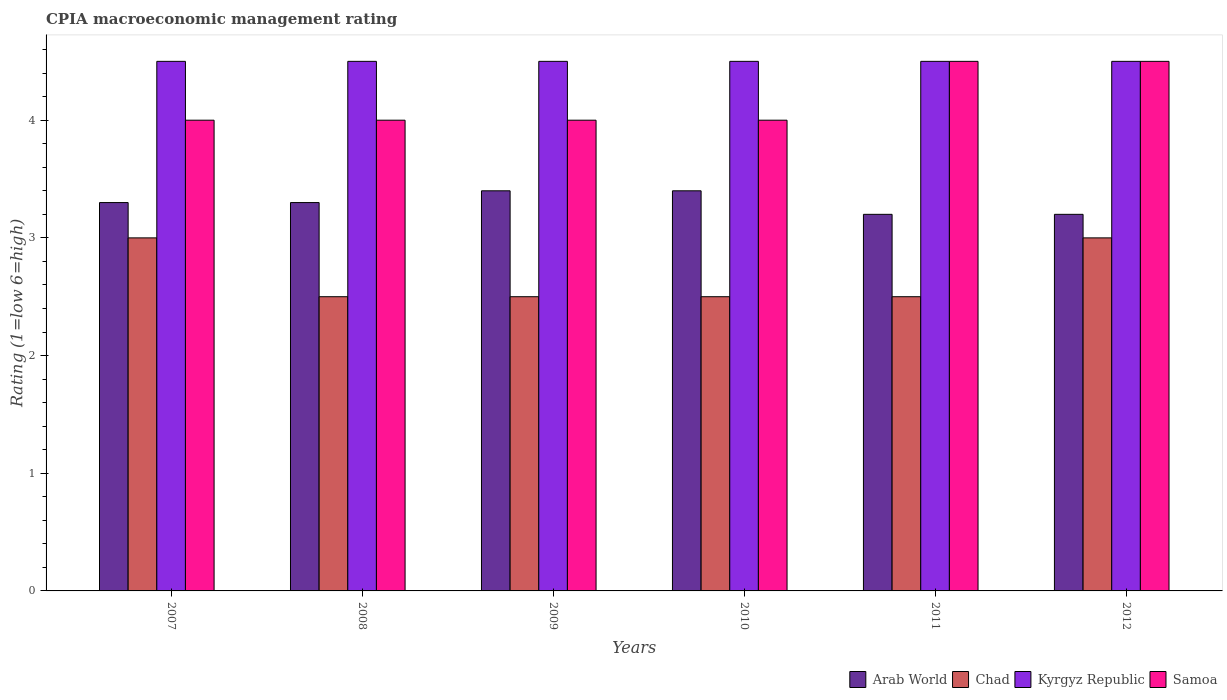Are the number of bars per tick equal to the number of legend labels?
Your response must be concise. Yes. Are the number of bars on each tick of the X-axis equal?
Your answer should be compact. Yes. How many bars are there on the 2nd tick from the left?
Provide a short and direct response. 4. How many bars are there on the 1st tick from the right?
Your answer should be compact. 4. Across all years, what is the maximum CPIA rating in Arab World?
Offer a very short reply. 3.4. Across all years, what is the minimum CPIA rating in Arab World?
Keep it short and to the point. 3.2. In which year was the CPIA rating in Chad minimum?
Offer a very short reply. 2008. What is the total CPIA rating in Samoa in the graph?
Your answer should be very brief. 25. What is the difference between the CPIA rating in Arab World in 2007 and that in 2010?
Offer a terse response. -0.1. What is the difference between the CPIA rating in Chad in 2010 and the CPIA rating in Kyrgyz Republic in 2012?
Provide a short and direct response. -2. What is the average CPIA rating in Arab World per year?
Make the answer very short. 3.3. In the year 2008, what is the difference between the CPIA rating in Chad and CPIA rating in Samoa?
Keep it short and to the point. -1.5. In how many years, is the CPIA rating in Kyrgyz Republic greater than 1.8?
Keep it short and to the point. 6. What is the ratio of the CPIA rating in Samoa in 2010 to that in 2012?
Give a very brief answer. 0.89. What is the difference between the highest and the lowest CPIA rating in Kyrgyz Republic?
Offer a very short reply. 0. Is the sum of the CPIA rating in Samoa in 2010 and 2012 greater than the maximum CPIA rating in Arab World across all years?
Your response must be concise. Yes. What does the 1st bar from the left in 2009 represents?
Your response must be concise. Arab World. What does the 1st bar from the right in 2007 represents?
Keep it short and to the point. Samoa. Is it the case that in every year, the sum of the CPIA rating in Kyrgyz Republic and CPIA rating in Arab World is greater than the CPIA rating in Chad?
Offer a very short reply. Yes. How many bars are there?
Offer a terse response. 24. Are all the bars in the graph horizontal?
Offer a very short reply. No. How many years are there in the graph?
Your response must be concise. 6. Where does the legend appear in the graph?
Your response must be concise. Bottom right. How are the legend labels stacked?
Offer a terse response. Horizontal. What is the title of the graph?
Make the answer very short. CPIA macroeconomic management rating. Does "Greece" appear as one of the legend labels in the graph?
Ensure brevity in your answer.  No. What is the label or title of the Y-axis?
Your answer should be very brief. Rating (1=low 6=high). What is the Rating (1=low 6=high) in Arab World in 2007?
Provide a short and direct response. 3.3. What is the Rating (1=low 6=high) in Samoa in 2008?
Make the answer very short. 4. What is the Rating (1=low 6=high) in Samoa in 2009?
Provide a succinct answer. 4. What is the Rating (1=low 6=high) of Chad in 2010?
Provide a short and direct response. 2.5. What is the Rating (1=low 6=high) of Kyrgyz Republic in 2010?
Provide a short and direct response. 4.5. What is the Rating (1=low 6=high) of Chad in 2011?
Keep it short and to the point. 2.5. What is the Rating (1=low 6=high) in Kyrgyz Republic in 2011?
Your response must be concise. 4.5. What is the Rating (1=low 6=high) of Samoa in 2011?
Your response must be concise. 4.5. What is the Rating (1=low 6=high) in Arab World in 2012?
Your response must be concise. 3.2. What is the Rating (1=low 6=high) of Chad in 2012?
Provide a succinct answer. 3. Across all years, what is the maximum Rating (1=low 6=high) in Kyrgyz Republic?
Ensure brevity in your answer.  4.5. Across all years, what is the minimum Rating (1=low 6=high) of Kyrgyz Republic?
Make the answer very short. 4.5. What is the total Rating (1=low 6=high) in Arab World in the graph?
Ensure brevity in your answer.  19.8. What is the total Rating (1=low 6=high) in Chad in the graph?
Your answer should be compact. 16. What is the difference between the Rating (1=low 6=high) in Arab World in 2007 and that in 2008?
Provide a succinct answer. 0. What is the difference between the Rating (1=low 6=high) in Chad in 2007 and that in 2008?
Your answer should be compact. 0.5. What is the difference between the Rating (1=low 6=high) of Kyrgyz Republic in 2007 and that in 2008?
Provide a succinct answer. 0. What is the difference between the Rating (1=low 6=high) of Chad in 2007 and that in 2010?
Your answer should be compact. 0.5. What is the difference between the Rating (1=low 6=high) in Chad in 2007 and that in 2011?
Ensure brevity in your answer.  0.5. What is the difference between the Rating (1=low 6=high) in Arab World in 2008 and that in 2009?
Offer a terse response. -0.1. What is the difference between the Rating (1=low 6=high) in Kyrgyz Republic in 2008 and that in 2010?
Offer a terse response. 0. What is the difference between the Rating (1=low 6=high) of Arab World in 2008 and that in 2011?
Provide a succinct answer. 0.1. What is the difference between the Rating (1=low 6=high) of Chad in 2008 and that in 2012?
Your answer should be very brief. -0.5. What is the difference between the Rating (1=low 6=high) in Samoa in 2008 and that in 2012?
Offer a very short reply. -0.5. What is the difference between the Rating (1=low 6=high) of Arab World in 2009 and that in 2010?
Provide a succinct answer. 0. What is the difference between the Rating (1=low 6=high) of Chad in 2009 and that in 2010?
Offer a very short reply. 0. What is the difference between the Rating (1=low 6=high) of Chad in 2009 and that in 2011?
Provide a succinct answer. 0. What is the difference between the Rating (1=low 6=high) of Samoa in 2009 and that in 2011?
Offer a very short reply. -0.5. What is the difference between the Rating (1=low 6=high) in Arab World in 2009 and that in 2012?
Your response must be concise. 0.2. What is the difference between the Rating (1=low 6=high) in Chad in 2009 and that in 2012?
Your answer should be very brief. -0.5. What is the difference between the Rating (1=low 6=high) of Kyrgyz Republic in 2009 and that in 2012?
Your answer should be compact. 0. What is the difference between the Rating (1=low 6=high) of Arab World in 2010 and that in 2011?
Give a very brief answer. 0.2. What is the difference between the Rating (1=low 6=high) of Samoa in 2010 and that in 2011?
Give a very brief answer. -0.5. What is the difference between the Rating (1=low 6=high) in Chad in 2010 and that in 2012?
Provide a succinct answer. -0.5. What is the difference between the Rating (1=low 6=high) in Samoa in 2010 and that in 2012?
Your answer should be compact. -0.5. What is the difference between the Rating (1=low 6=high) in Chad in 2011 and that in 2012?
Ensure brevity in your answer.  -0.5. What is the difference between the Rating (1=low 6=high) in Kyrgyz Republic in 2011 and that in 2012?
Provide a succinct answer. 0. What is the difference between the Rating (1=low 6=high) of Arab World in 2007 and the Rating (1=low 6=high) of Chad in 2008?
Provide a short and direct response. 0.8. What is the difference between the Rating (1=low 6=high) in Arab World in 2007 and the Rating (1=low 6=high) in Kyrgyz Republic in 2009?
Your answer should be very brief. -1.2. What is the difference between the Rating (1=low 6=high) in Chad in 2007 and the Rating (1=low 6=high) in Samoa in 2009?
Your response must be concise. -1. What is the difference between the Rating (1=low 6=high) in Kyrgyz Republic in 2007 and the Rating (1=low 6=high) in Samoa in 2009?
Your answer should be compact. 0.5. What is the difference between the Rating (1=low 6=high) in Arab World in 2007 and the Rating (1=low 6=high) in Chad in 2010?
Provide a short and direct response. 0.8. What is the difference between the Rating (1=low 6=high) in Arab World in 2007 and the Rating (1=low 6=high) in Kyrgyz Republic in 2010?
Give a very brief answer. -1.2. What is the difference between the Rating (1=low 6=high) in Arab World in 2007 and the Rating (1=low 6=high) in Samoa in 2010?
Your response must be concise. -0.7. What is the difference between the Rating (1=low 6=high) in Chad in 2007 and the Rating (1=low 6=high) in Kyrgyz Republic in 2010?
Your response must be concise. -1.5. What is the difference between the Rating (1=low 6=high) of Chad in 2007 and the Rating (1=low 6=high) of Samoa in 2010?
Give a very brief answer. -1. What is the difference between the Rating (1=low 6=high) in Kyrgyz Republic in 2007 and the Rating (1=low 6=high) in Samoa in 2010?
Provide a succinct answer. 0.5. What is the difference between the Rating (1=low 6=high) in Arab World in 2007 and the Rating (1=low 6=high) in Kyrgyz Republic in 2011?
Give a very brief answer. -1.2. What is the difference between the Rating (1=low 6=high) in Arab World in 2007 and the Rating (1=low 6=high) in Samoa in 2011?
Give a very brief answer. -1.2. What is the difference between the Rating (1=low 6=high) of Arab World in 2007 and the Rating (1=low 6=high) of Samoa in 2012?
Your response must be concise. -1.2. What is the difference between the Rating (1=low 6=high) of Chad in 2007 and the Rating (1=low 6=high) of Samoa in 2012?
Provide a short and direct response. -1.5. What is the difference between the Rating (1=low 6=high) in Arab World in 2008 and the Rating (1=low 6=high) in Kyrgyz Republic in 2009?
Your answer should be very brief. -1.2. What is the difference between the Rating (1=low 6=high) of Chad in 2008 and the Rating (1=low 6=high) of Kyrgyz Republic in 2009?
Ensure brevity in your answer.  -2. What is the difference between the Rating (1=low 6=high) in Chad in 2008 and the Rating (1=low 6=high) in Samoa in 2009?
Provide a succinct answer. -1.5. What is the difference between the Rating (1=low 6=high) of Arab World in 2008 and the Rating (1=low 6=high) of Chad in 2010?
Your answer should be compact. 0.8. What is the difference between the Rating (1=low 6=high) of Chad in 2008 and the Rating (1=low 6=high) of Samoa in 2010?
Make the answer very short. -1.5. What is the difference between the Rating (1=low 6=high) of Kyrgyz Republic in 2008 and the Rating (1=low 6=high) of Samoa in 2010?
Your answer should be very brief. 0.5. What is the difference between the Rating (1=low 6=high) in Arab World in 2008 and the Rating (1=low 6=high) in Kyrgyz Republic in 2011?
Offer a very short reply. -1.2. What is the difference between the Rating (1=low 6=high) in Chad in 2008 and the Rating (1=low 6=high) in Kyrgyz Republic in 2011?
Your answer should be very brief. -2. What is the difference between the Rating (1=low 6=high) in Kyrgyz Republic in 2008 and the Rating (1=low 6=high) in Samoa in 2011?
Ensure brevity in your answer.  0. What is the difference between the Rating (1=low 6=high) of Chad in 2008 and the Rating (1=low 6=high) of Kyrgyz Republic in 2012?
Provide a short and direct response. -2. What is the difference between the Rating (1=low 6=high) of Chad in 2008 and the Rating (1=low 6=high) of Samoa in 2012?
Provide a short and direct response. -2. What is the difference between the Rating (1=low 6=high) in Arab World in 2009 and the Rating (1=low 6=high) in Samoa in 2010?
Give a very brief answer. -0.6. What is the difference between the Rating (1=low 6=high) in Chad in 2009 and the Rating (1=low 6=high) in Kyrgyz Republic in 2010?
Ensure brevity in your answer.  -2. What is the difference between the Rating (1=low 6=high) in Chad in 2009 and the Rating (1=low 6=high) in Samoa in 2010?
Make the answer very short. -1.5. What is the difference between the Rating (1=low 6=high) of Arab World in 2009 and the Rating (1=low 6=high) of Chad in 2011?
Offer a terse response. 0.9. What is the difference between the Rating (1=low 6=high) in Kyrgyz Republic in 2009 and the Rating (1=low 6=high) in Samoa in 2011?
Keep it short and to the point. 0. What is the difference between the Rating (1=low 6=high) in Arab World in 2009 and the Rating (1=low 6=high) in Samoa in 2012?
Ensure brevity in your answer.  -1.1. What is the difference between the Rating (1=low 6=high) in Chad in 2009 and the Rating (1=low 6=high) in Kyrgyz Republic in 2012?
Your answer should be very brief. -2. What is the difference between the Rating (1=low 6=high) in Arab World in 2010 and the Rating (1=low 6=high) in Chad in 2011?
Make the answer very short. 0.9. What is the difference between the Rating (1=low 6=high) in Chad in 2010 and the Rating (1=low 6=high) in Kyrgyz Republic in 2011?
Provide a succinct answer. -2. What is the difference between the Rating (1=low 6=high) of Chad in 2010 and the Rating (1=low 6=high) of Samoa in 2011?
Your answer should be compact. -2. What is the difference between the Rating (1=low 6=high) in Kyrgyz Republic in 2010 and the Rating (1=low 6=high) in Samoa in 2011?
Keep it short and to the point. 0. What is the difference between the Rating (1=low 6=high) of Arab World in 2010 and the Rating (1=low 6=high) of Chad in 2012?
Give a very brief answer. 0.4. What is the difference between the Rating (1=low 6=high) in Arab World in 2010 and the Rating (1=low 6=high) in Kyrgyz Republic in 2012?
Provide a succinct answer. -1.1. What is the difference between the Rating (1=low 6=high) in Chad in 2010 and the Rating (1=low 6=high) in Samoa in 2012?
Your answer should be very brief. -2. What is the difference between the Rating (1=low 6=high) of Arab World in 2011 and the Rating (1=low 6=high) of Kyrgyz Republic in 2012?
Keep it short and to the point. -1.3. What is the difference between the Rating (1=low 6=high) of Arab World in 2011 and the Rating (1=low 6=high) of Samoa in 2012?
Offer a terse response. -1.3. What is the difference between the Rating (1=low 6=high) in Kyrgyz Republic in 2011 and the Rating (1=low 6=high) in Samoa in 2012?
Give a very brief answer. 0. What is the average Rating (1=low 6=high) of Chad per year?
Offer a very short reply. 2.67. What is the average Rating (1=low 6=high) of Kyrgyz Republic per year?
Your response must be concise. 4.5. What is the average Rating (1=low 6=high) in Samoa per year?
Offer a terse response. 4.17. In the year 2007, what is the difference between the Rating (1=low 6=high) of Kyrgyz Republic and Rating (1=low 6=high) of Samoa?
Provide a succinct answer. 0.5. In the year 2008, what is the difference between the Rating (1=low 6=high) in Arab World and Rating (1=low 6=high) in Kyrgyz Republic?
Give a very brief answer. -1.2. In the year 2008, what is the difference between the Rating (1=low 6=high) of Arab World and Rating (1=low 6=high) of Samoa?
Your answer should be very brief. -0.7. In the year 2008, what is the difference between the Rating (1=low 6=high) of Chad and Rating (1=low 6=high) of Kyrgyz Republic?
Provide a succinct answer. -2. In the year 2008, what is the difference between the Rating (1=low 6=high) of Kyrgyz Republic and Rating (1=low 6=high) of Samoa?
Your answer should be very brief. 0.5. In the year 2009, what is the difference between the Rating (1=low 6=high) of Arab World and Rating (1=low 6=high) of Chad?
Your answer should be very brief. 0.9. In the year 2009, what is the difference between the Rating (1=low 6=high) of Arab World and Rating (1=low 6=high) of Kyrgyz Republic?
Keep it short and to the point. -1.1. In the year 2009, what is the difference between the Rating (1=low 6=high) in Arab World and Rating (1=low 6=high) in Samoa?
Provide a succinct answer. -0.6. In the year 2009, what is the difference between the Rating (1=low 6=high) in Chad and Rating (1=low 6=high) in Kyrgyz Republic?
Ensure brevity in your answer.  -2. In the year 2009, what is the difference between the Rating (1=low 6=high) of Chad and Rating (1=low 6=high) of Samoa?
Ensure brevity in your answer.  -1.5. In the year 2010, what is the difference between the Rating (1=low 6=high) of Kyrgyz Republic and Rating (1=low 6=high) of Samoa?
Ensure brevity in your answer.  0.5. In the year 2011, what is the difference between the Rating (1=low 6=high) of Arab World and Rating (1=low 6=high) of Samoa?
Give a very brief answer. -1.3. In the year 2011, what is the difference between the Rating (1=low 6=high) of Chad and Rating (1=low 6=high) of Kyrgyz Republic?
Provide a succinct answer. -2. In the year 2011, what is the difference between the Rating (1=low 6=high) in Chad and Rating (1=low 6=high) in Samoa?
Your answer should be compact. -2. In the year 2011, what is the difference between the Rating (1=low 6=high) in Kyrgyz Republic and Rating (1=low 6=high) in Samoa?
Provide a short and direct response. 0. In the year 2012, what is the difference between the Rating (1=low 6=high) in Arab World and Rating (1=low 6=high) in Samoa?
Your answer should be compact. -1.3. In the year 2012, what is the difference between the Rating (1=low 6=high) in Chad and Rating (1=low 6=high) in Kyrgyz Republic?
Keep it short and to the point. -1.5. What is the ratio of the Rating (1=low 6=high) in Chad in 2007 to that in 2008?
Provide a succinct answer. 1.2. What is the ratio of the Rating (1=low 6=high) in Kyrgyz Republic in 2007 to that in 2008?
Keep it short and to the point. 1. What is the ratio of the Rating (1=low 6=high) in Arab World in 2007 to that in 2009?
Your answer should be compact. 0.97. What is the ratio of the Rating (1=low 6=high) in Chad in 2007 to that in 2009?
Ensure brevity in your answer.  1.2. What is the ratio of the Rating (1=low 6=high) in Kyrgyz Republic in 2007 to that in 2009?
Your answer should be very brief. 1. What is the ratio of the Rating (1=low 6=high) in Samoa in 2007 to that in 2009?
Offer a very short reply. 1. What is the ratio of the Rating (1=low 6=high) in Arab World in 2007 to that in 2010?
Your answer should be very brief. 0.97. What is the ratio of the Rating (1=low 6=high) in Chad in 2007 to that in 2010?
Your answer should be compact. 1.2. What is the ratio of the Rating (1=low 6=high) of Kyrgyz Republic in 2007 to that in 2010?
Offer a terse response. 1. What is the ratio of the Rating (1=low 6=high) of Arab World in 2007 to that in 2011?
Ensure brevity in your answer.  1.03. What is the ratio of the Rating (1=low 6=high) in Chad in 2007 to that in 2011?
Provide a succinct answer. 1.2. What is the ratio of the Rating (1=low 6=high) in Kyrgyz Republic in 2007 to that in 2011?
Give a very brief answer. 1. What is the ratio of the Rating (1=low 6=high) in Arab World in 2007 to that in 2012?
Provide a succinct answer. 1.03. What is the ratio of the Rating (1=low 6=high) in Chad in 2007 to that in 2012?
Your answer should be compact. 1. What is the ratio of the Rating (1=low 6=high) of Kyrgyz Republic in 2007 to that in 2012?
Keep it short and to the point. 1. What is the ratio of the Rating (1=low 6=high) in Arab World in 2008 to that in 2009?
Provide a short and direct response. 0.97. What is the ratio of the Rating (1=low 6=high) in Chad in 2008 to that in 2009?
Give a very brief answer. 1. What is the ratio of the Rating (1=low 6=high) in Kyrgyz Republic in 2008 to that in 2009?
Offer a very short reply. 1. What is the ratio of the Rating (1=low 6=high) in Samoa in 2008 to that in 2009?
Your answer should be very brief. 1. What is the ratio of the Rating (1=low 6=high) in Arab World in 2008 to that in 2010?
Keep it short and to the point. 0.97. What is the ratio of the Rating (1=low 6=high) of Chad in 2008 to that in 2010?
Offer a very short reply. 1. What is the ratio of the Rating (1=low 6=high) of Samoa in 2008 to that in 2010?
Keep it short and to the point. 1. What is the ratio of the Rating (1=low 6=high) in Arab World in 2008 to that in 2011?
Your answer should be very brief. 1.03. What is the ratio of the Rating (1=low 6=high) of Arab World in 2008 to that in 2012?
Your answer should be very brief. 1.03. What is the ratio of the Rating (1=low 6=high) in Chad in 2008 to that in 2012?
Your answer should be compact. 0.83. What is the ratio of the Rating (1=low 6=high) of Kyrgyz Republic in 2008 to that in 2012?
Ensure brevity in your answer.  1. What is the ratio of the Rating (1=low 6=high) of Samoa in 2008 to that in 2012?
Offer a very short reply. 0.89. What is the ratio of the Rating (1=low 6=high) in Chad in 2009 to that in 2011?
Offer a terse response. 1. What is the ratio of the Rating (1=low 6=high) in Kyrgyz Republic in 2009 to that in 2011?
Provide a short and direct response. 1. What is the ratio of the Rating (1=low 6=high) in Samoa in 2009 to that in 2011?
Provide a short and direct response. 0.89. What is the ratio of the Rating (1=low 6=high) in Kyrgyz Republic in 2009 to that in 2012?
Your response must be concise. 1. What is the ratio of the Rating (1=low 6=high) of Samoa in 2009 to that in 2012?
Offer a terse response. 0.89. What is the ratio of the Rating (1=low 6=high) in Chad in 2010 to that in 2011?
Offer a terse response. 1. What is the ratio of the Rating (1=low 6=high) of Arab World in 2010 to that in 2012?
Offer a very short reply. 1.06. What is the ratio of the Rating (1=low 6=high) in Samoa in 2010 to that in 2012?
Make the answer very short. 0.89. What is the ratio of the Rating (1=low 6=high) of Chad in 2011 to that in 2012?
Give a very brief answer. 0.83. What is the ratio of the Rating (1=low 6=high) of Kyrgyz Republic in 2011 to that in 2012?
Offer a very short reply. 1. What is the difference between the highest and the second highest Rating (1=low 6=high) of Chad?
Your answer should be very brief. 0. What is the difference between the highest and the second highest Rating (1=low 6=high) of Kyrgyz Republic?
Give a very brief answer. 0. What is the difference between the highest and the lowest Rating (1=low 6=high) in Chad?
Your answer should be compact. 0.5. 